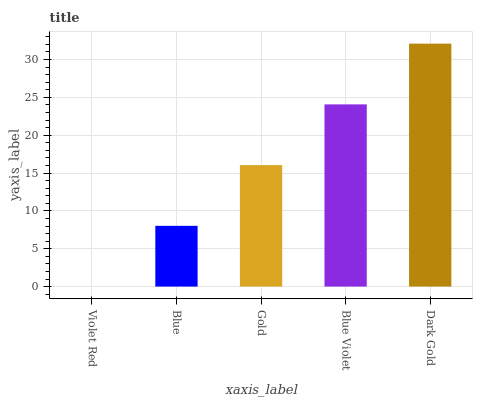Is Violet Red the minimum?
Answer yes or no. Yes. Is Dark Gold the maximum?
Answer yes or no. Yes. Is Blue the minimum?
Answer yes or no. No. Is Blue the maximum?
Answer yes or no. No. Is Blue greater than Violet Red?
Answer yes or no. Yes. Is Violet Red less than Blue?
Answer yes or no. Yes. Is Violet Red greater than Blue?
Answer yes or no. No. Is Blue less than Violet Red?
Answer yes or no. No. Is Gold the high median?
Answer yes or no. Yes. Is Gold the low median?
Answer yes or no. Yes. Is Violet Red the high median?
Answer yes or no. No. Is Blue the low median?
Answer yes or no. No. 